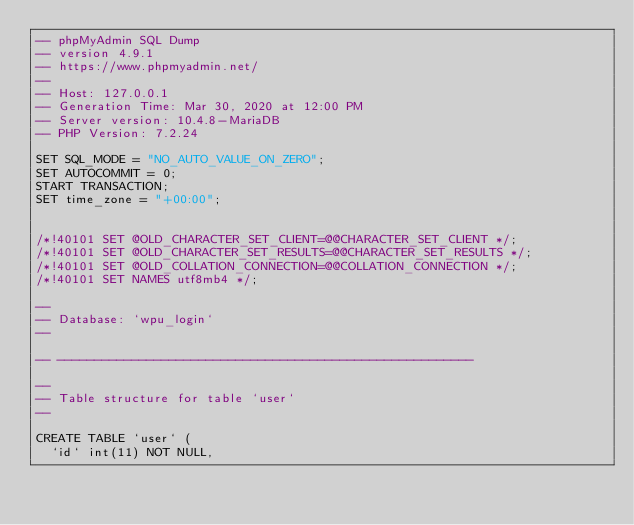<code> <loc_0><loc_0><loc_500><loc_500><_SQL_>-- phpMyAdmin SQL Dump
-- version 4.9.1
-- https://www.phpmyadmin.net/
--
-- Host: 127.0.0.1
-- Generation Time: Mar 30, 2020 at 12:00 PM
-- Server version: 10.4.8-MariaDB
-- PHP Version: 7.2.24

SET SQL_MODE = "NO_AUTO_VALUE_ON_ZERO";
SET AUTOCOMMIT = 0;
START TRANSACTION;
SET time_zone = "+00:00";


/*!40101 SET @OLD_CHARACTER_SET_CLIENT=@@CHARACTER_SET_CLIENT */;
/*!40101 SET @OLD_CHARACTER_SET_RESULTS=@@CHARACTER_SET_RESULTS */;
/*!40101 SET @OLD_COLLATION_CONNECTION=@@COLLATION_CONNECTION */;
/*!40101 SET NAMES utf8mb4 */;

--
-- Database: `wpu_login`
--

-- --------------------------------------------------------

--
-- Table structure for table `user`
--

CREATE TABLE `user` (
  `id` int(11) NOT NULL,</code> 